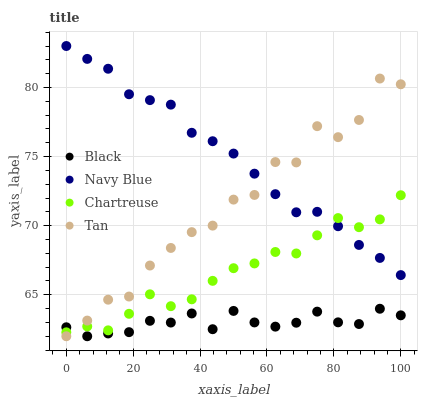Does Black have the minimum area under the curve?
Answer yes or no. Yes. Does Navy Blue have the maximum area under the curve?
Answer yes or no. Yes. Does Chartreuse have the minimum area under the curve?
Answer yes or no. No. Does Chartreuse have the maximum area under the curve?
Answer yes or no. No. Is Navy Blue the smoothest?
Answer yes or no. Yes. Is Tan the roughest?
Answer yes or no. Yes. Is Chartreuse the smoothest?
Answer yes or no. No. Is Chartreuse the roughest?
Answer yes or no. No. Does Black have the lowest value?
Answer yes or no. Yes. Does Chartreuse have the lowest value?
Answer yes or no. No. Does Navy Blue have the highest value?
Answer yes or no. Yes. Does Chartreuse have the highest value?
Answer yes or no. No. Is Black less than Navy Blue?
Answer yes or no. Yes. Is Navy Blue greater than Black?
Answer yes or no. Yes. Does Tan intersect Navy Blue?
Answer yes or no. Yes. Is Tan less than Navy Blue?
Answer yes or no. No. Is Tan greater than Navy Blue?
Answer yes or no. No. Does Black intersect Navy Blue?
Answer yes or no. No. 